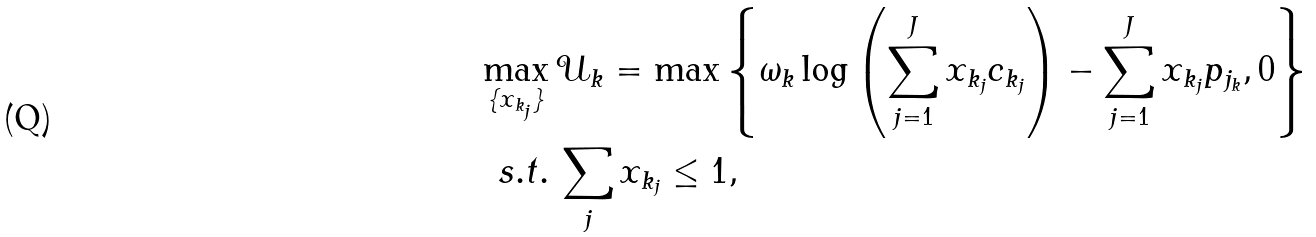Convert formula to latex. <formula><loc_0><loc_0><loc_500><loc_500>\max _ { \{ x _ { k _ { j } } \} } & \, \mathcal { U } _ { k } = \max \left \{ \omega _ { k } \log \left ( \sum _ { j = 1 } ^ { J } x _ { k _ { j } } c _ { k _ { j } } \right ) - \sum _ { j = 1 } ^ { J } x _ { k _ { j } } p _ { j _ { k } } , 0 \right \} \\ s . t . & \, \sum _ { j } x _ { k _ { j } } \leq 1 ,</formula> 